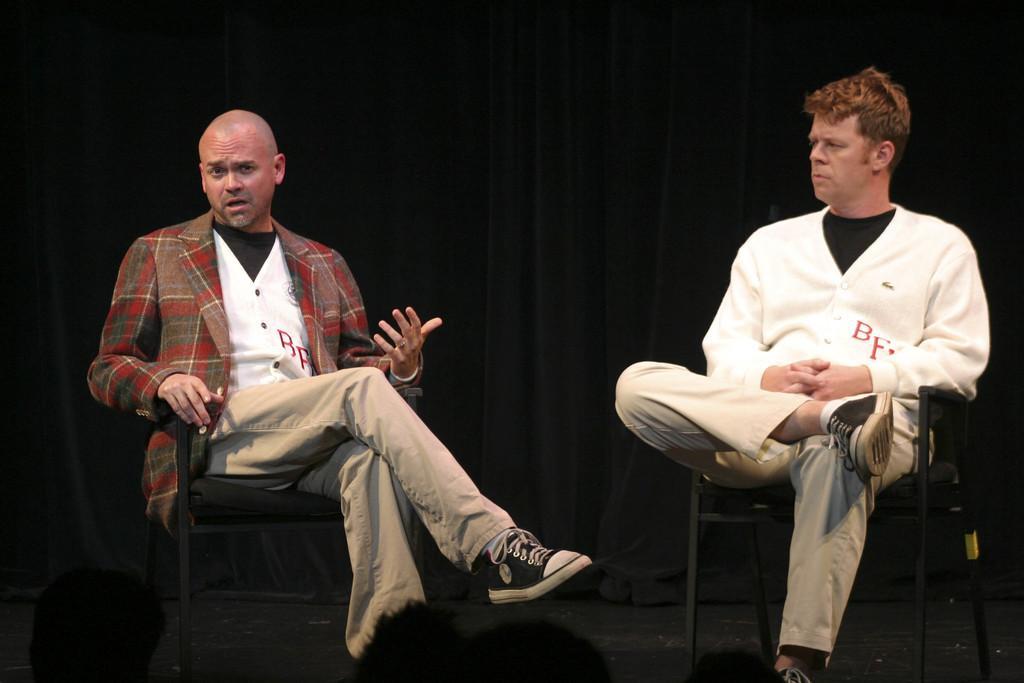In one or two sentences, can you explain what this image depicts? In this image, we can see two men sitting on the chairs. In the background, we can see a curtain. 